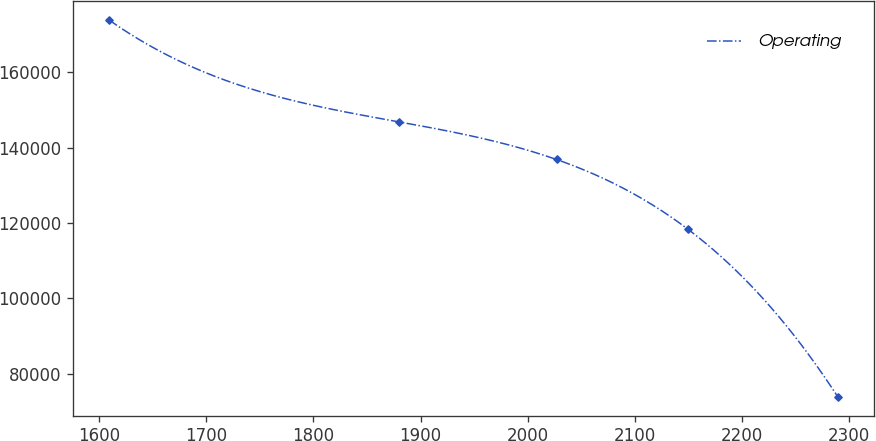<chart> <loc_0><loc_0><loc_500><loc_500><line_chart><ecel><fcel>Operating<nl><fcel>1609.01<fcel>173900<nl><fcel>1879.45<fcel>146867<nl><fcel>2027.02<fcel>136865<nl><fcel>2149.99<fcel>118311<nl><fcel>2289.74<fcel>73877.1<nl></chart> 